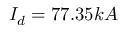Convert formula to latex. <formula><loc_0><loc_0><loc_500><loc_500>I _ { d } = 7 7 . 3 5 k A</formula> 